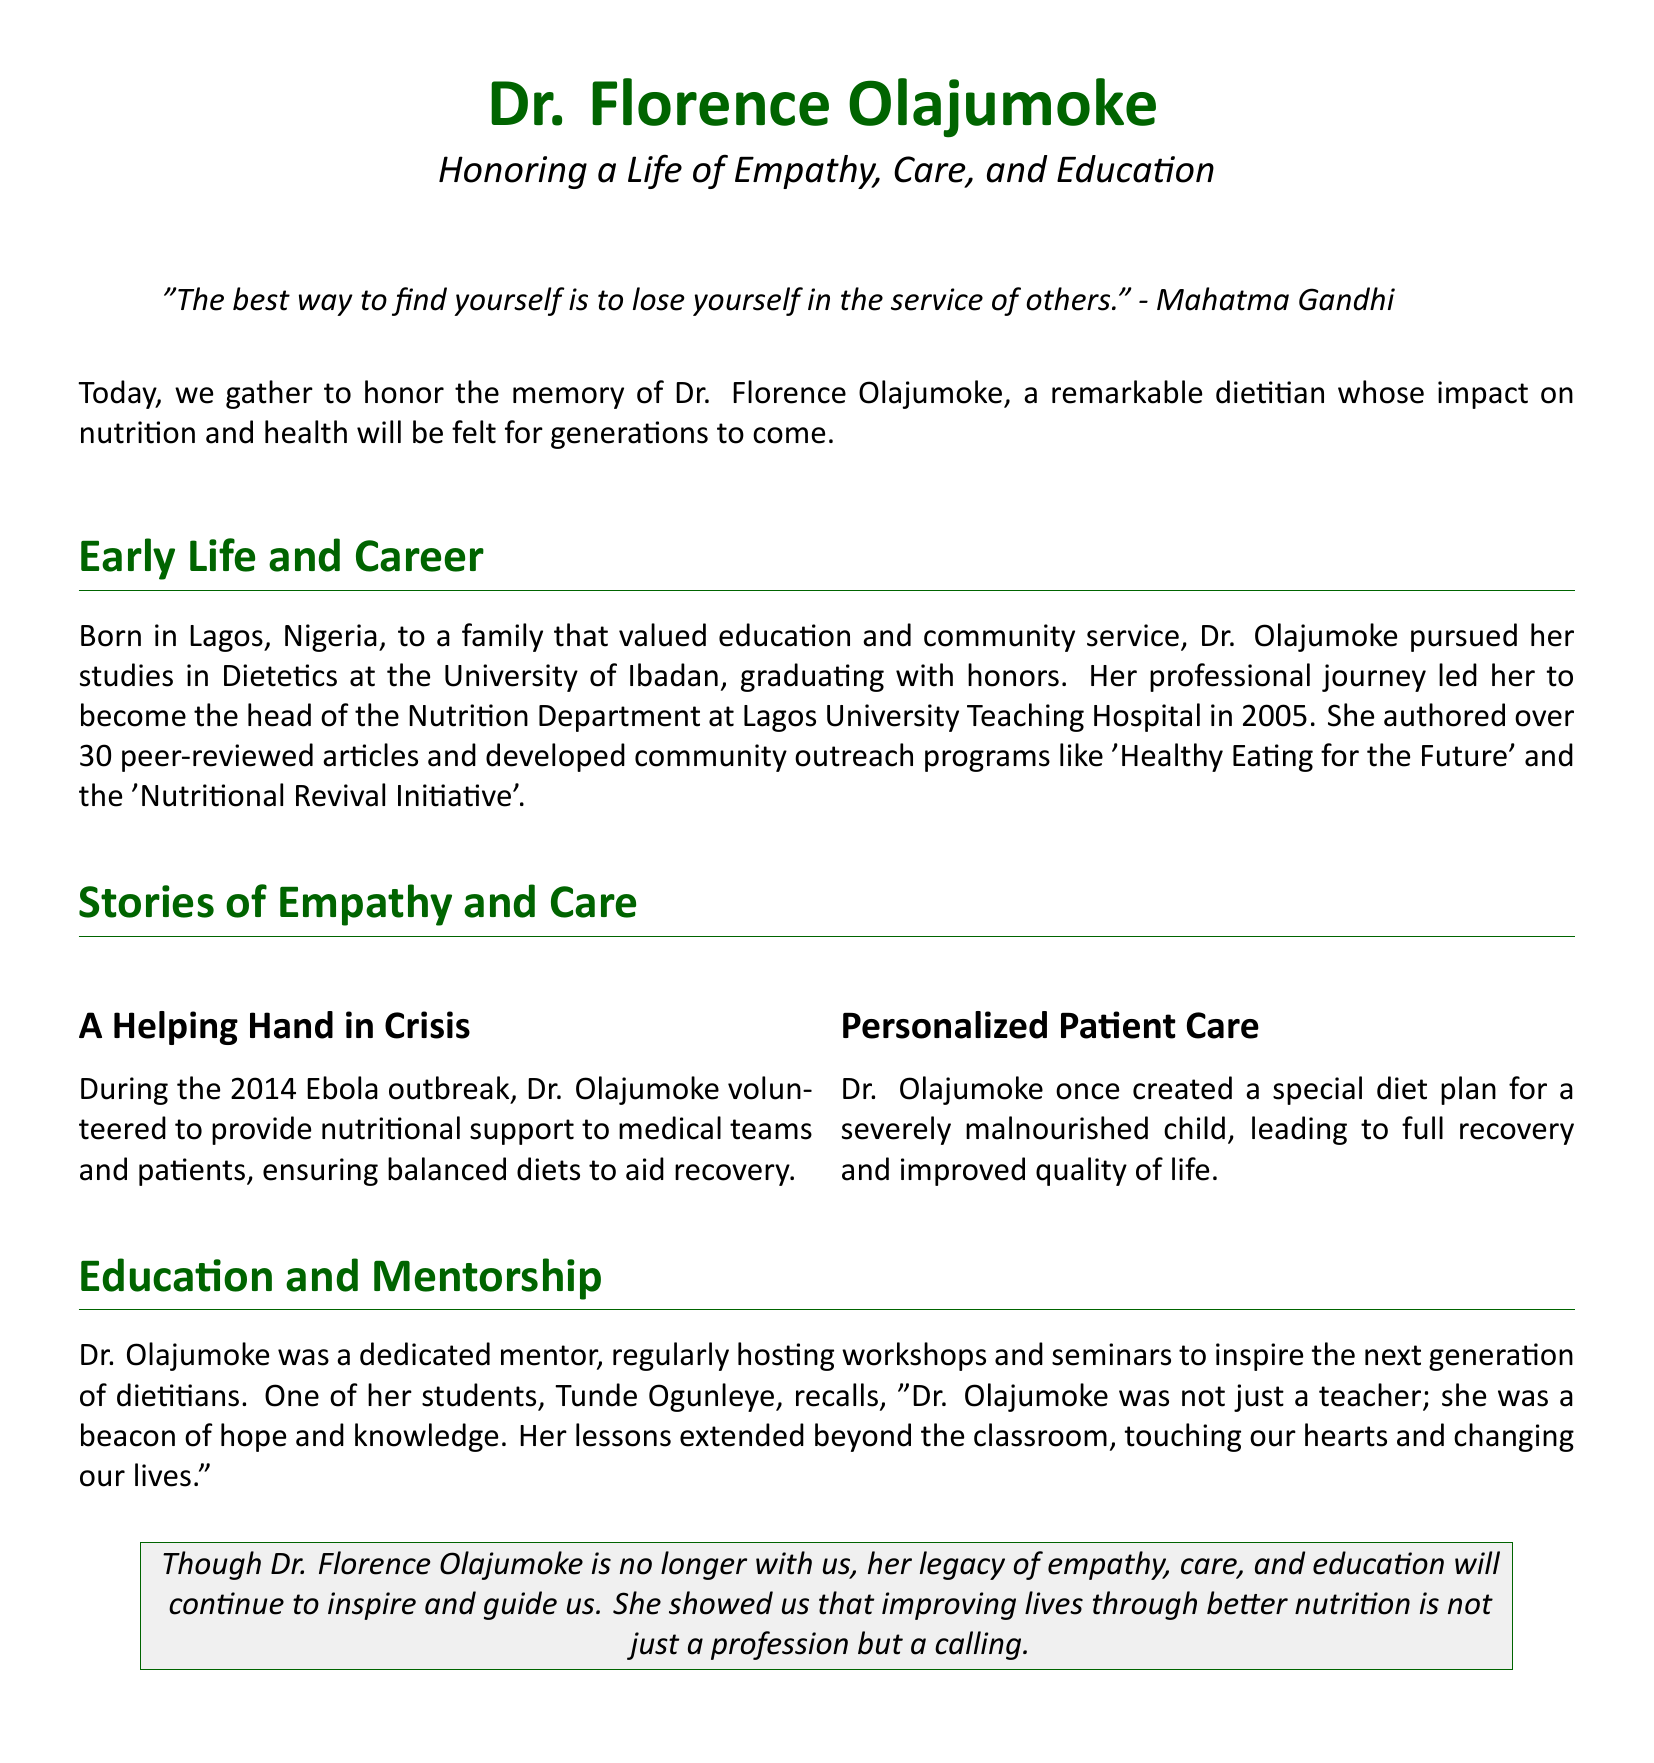What is the name of the dietitian being honored? The document is a eulogy honoring Dr. Florence Olajumoke, a renowned dietitian.
Answer: Dr. Florence Olajumoke What university did Dr. Olajumoke attend? The document mentions that she studied Dietetics at the University of Ibadan.
Answer: University of Ibadan In what year did Dr. Olajumoke become the head of the Nutrition Department? The document states that she became the head in 2005.
Answer: 2005 How many peer-reviewed articles did Dr. Olajumoke author? The document indicates that she authored over 30 peer-reviewed articles.
Answer: Over 30 What community outreach program did Dr. Olajumoke develop? The document lists 'Healthy Eating for the Future' as one of her community outreach programs.
Answer: Healthy Eating for the Future What significant event did Dr. Olajumoke volunteer during? The document mentions that she volunteered during the 2014 Ebola outbreak.
Answer: 2014 Ebola outbreak How did Dr. Olajumoke impact her students according to Tunde Ogunleye? The document includes a quote from Tunde Ogunleye describing her as a beacon of hope and knowledge.
Answer: Beacon of hope and knowledge What is the primary focus of the eulogy? The document's primary focus is on honoring Dr. Olajumoke's life of empathy, care, and education in dietetics.
Answer: Empathy, care, and education 